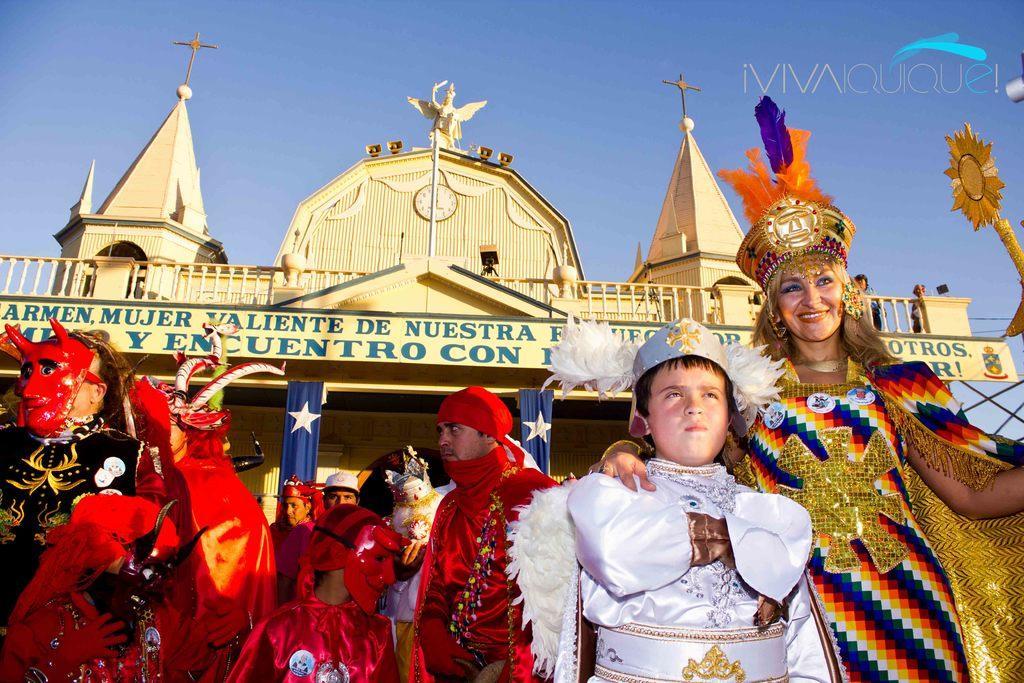Can you describe this image briefly? In this picture we can see the small boy wearing white dress, standing in the front with a woman, wearing golden costume, smiling and giving a pose to the camera. behind there are some people wearing red costume. In the background we can see the yellow building with statue on the top. 